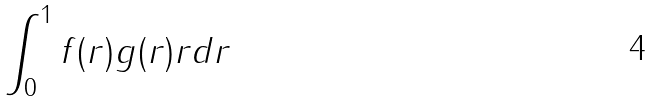<formula> <loc_0><loc_0><loc_500><loc_500>\int _ { 0 } ^ { 1 } f ( r ) g ( r ) r d r</formula> 